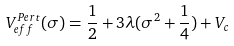Convert formula to latex. <formula><loc_0><loc_0><loc_500><loc_500>V _ { e f f } ^ { P e r t } ( \sigma ) = \frac { 1 } { 2 } + 3 \lambda ( \sigma ^ { 2 } + \frac { 1 } { 4 } ) + V _ { c }</formula> 